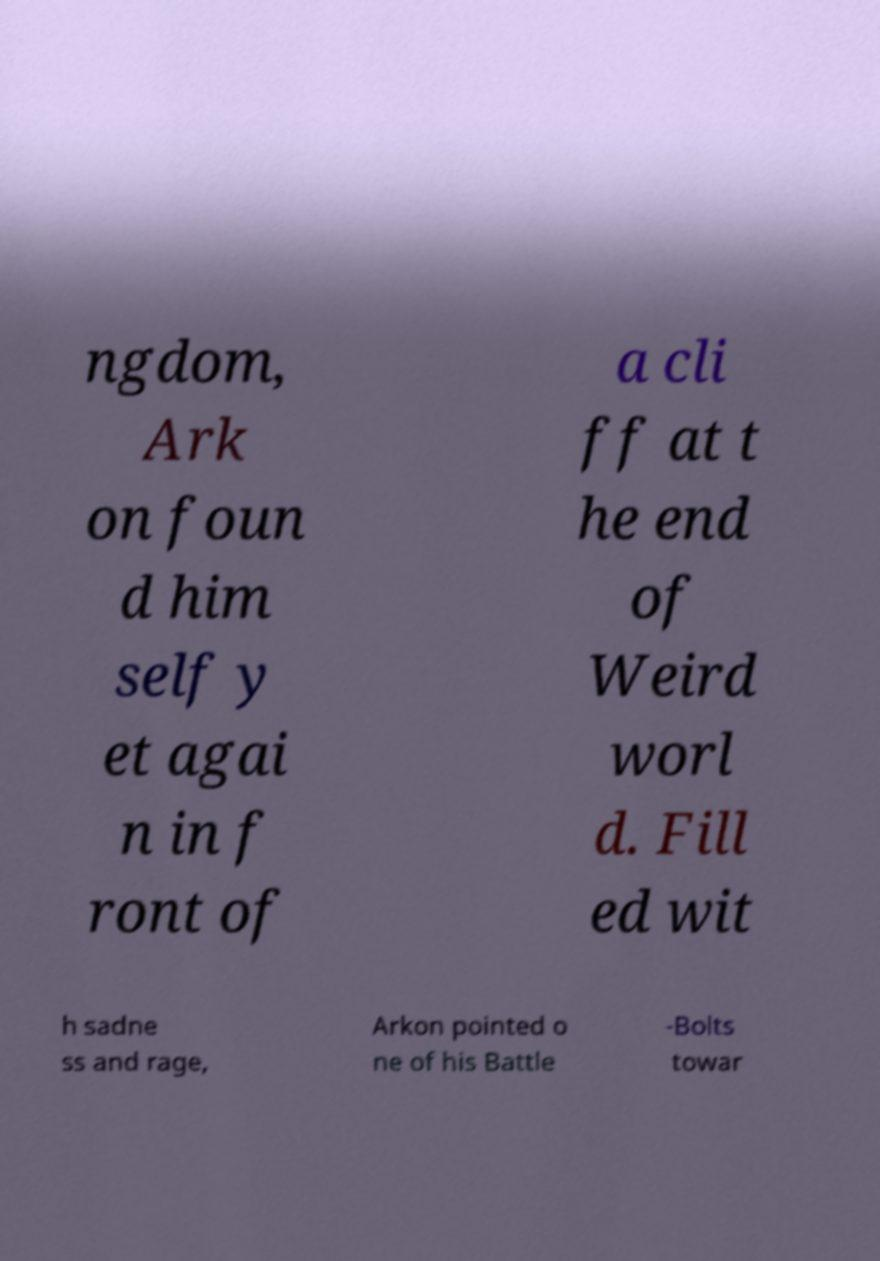I need the written content from this picture converted into text. Can you do that? ngdom, Ark on foun d him self y et agai n in f ront of a cli ff at t he end of Weird worl d. Fill ed wit h sadne ss and rage, Arkon pointed o ne of his Battle -Bolts towar 